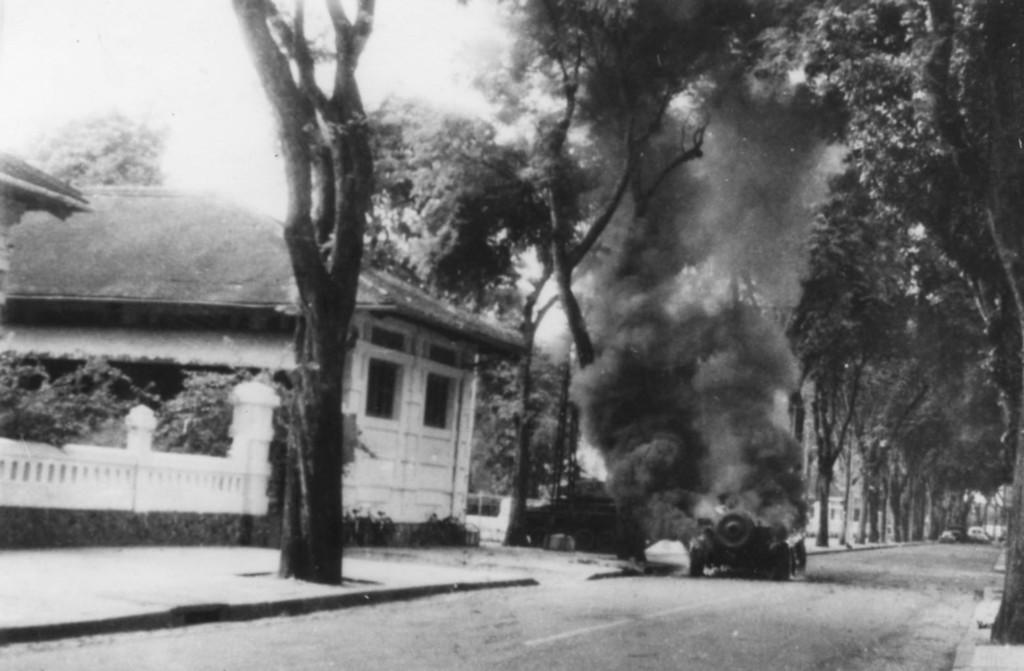What is the color scheme of the image? The image is black and white. What structure is located on the left side of the image? There is a house on the left side of the image. What is present in the middle of the image? A vehicle is burning in the middle of the image. What type of vegetation can be seen in the image? There are trees in the image. How many houses are present afterthought in the image? There is no concept of "afterthought" in the image, and only one house is visible on the left side. Was the burning vehicle caused by a bomb in the image? There is no mention of a bomb or any other cause for the burning vehicle in the image. 